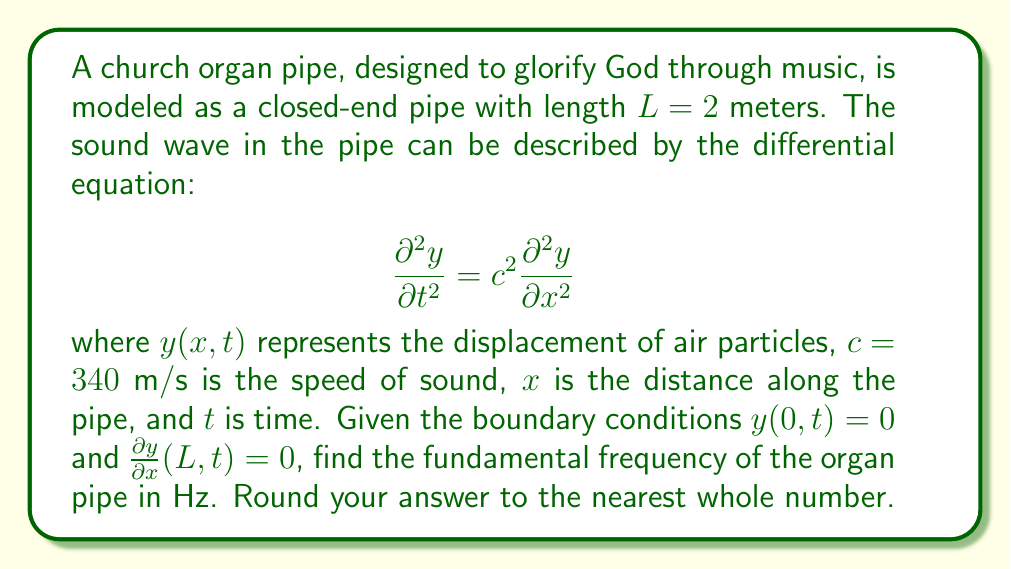Could you help me with this problem? Let's approach this problem step-by-step, remembering that our goal is to find the fundamental frequency of the organ pipe, which produces the beautiful music we hear in church.

1) For a closed-end pipe, the general solution to the wave equation is:

   $$y(x,t) = [A \cos(kx) + B \sin(kx)][C \cos(\omega t) + D \sin(\omega t)]$$

   where $k$ is the wave number and $\omega$ is the angular frequency.

2) Applying the boundary condition $y(0,t) = 0$:
   
   This implies $A = 0$, so our solution becomes:
   
   $$y(x,t) = B \sin(kx)[C \cos(\omega t) + D \sin(\omega t)]$$

3) Applying the boundary condition $\frac{\partial y}{\partial x}(L,t) = 0$:
   
   $$\frac{\partial y}{\partial x} = Bk \cos(kx)[C \cos(\omega t) + D \sin(\omega t)]$$
   
   At $x = L$, this should be zero, so:
   
   $$k \cos(kL) = 0$$

4) The solutions to this equation are:

   $$kL = \frac{\pi}{2}, \frac{3\pi}{2}, \frac{5\pi}{2}, ...$$

   Or more generally: $$kL = \frac{(2n-1)\pi}{2}$$ where $n = 1, 2, 3, ...$

5) The fundamental frequency corresponds to $n = 1$, so:

   $$k = \frac{\pi}{2L}$$

6) We know that $\omega = ck$, where $c$ is the speed of sound. So:

   $$\omega = c \cdot \frac{\pi}{2L}$$

7) The frequency $f$ is related to $\omega$ by $\omega = 2\pi f$, so:

   $$f = \frac{c}{4L}$$

8) Substituting the values $c = 340$ m/s and $L = 2$ m:

   $$f = \frac{340}{4 \cdot 2} = 42.5 \text{ Hz}$$

9) Rounding to the nearest whole number:

   $$f \approx 43 \text{ Hz}$$
Answer: $43 \text{ Hz}$ 